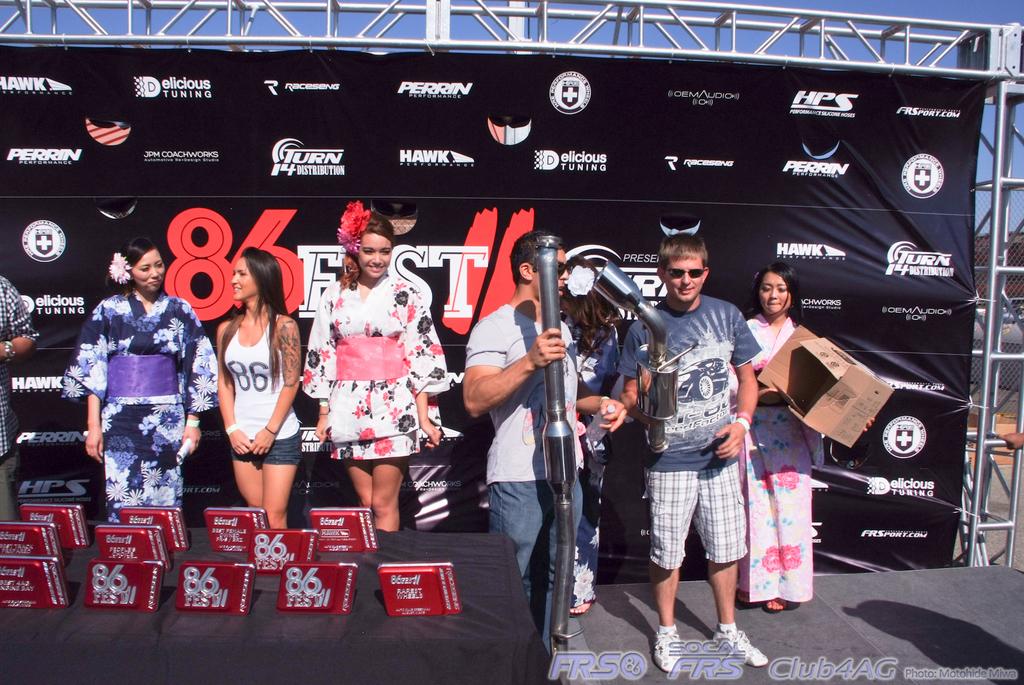What is the name of the festival being attended?
Your answer should be compact. 86 fest. What number is on the plaques?
Offer a very short reply. 86. 